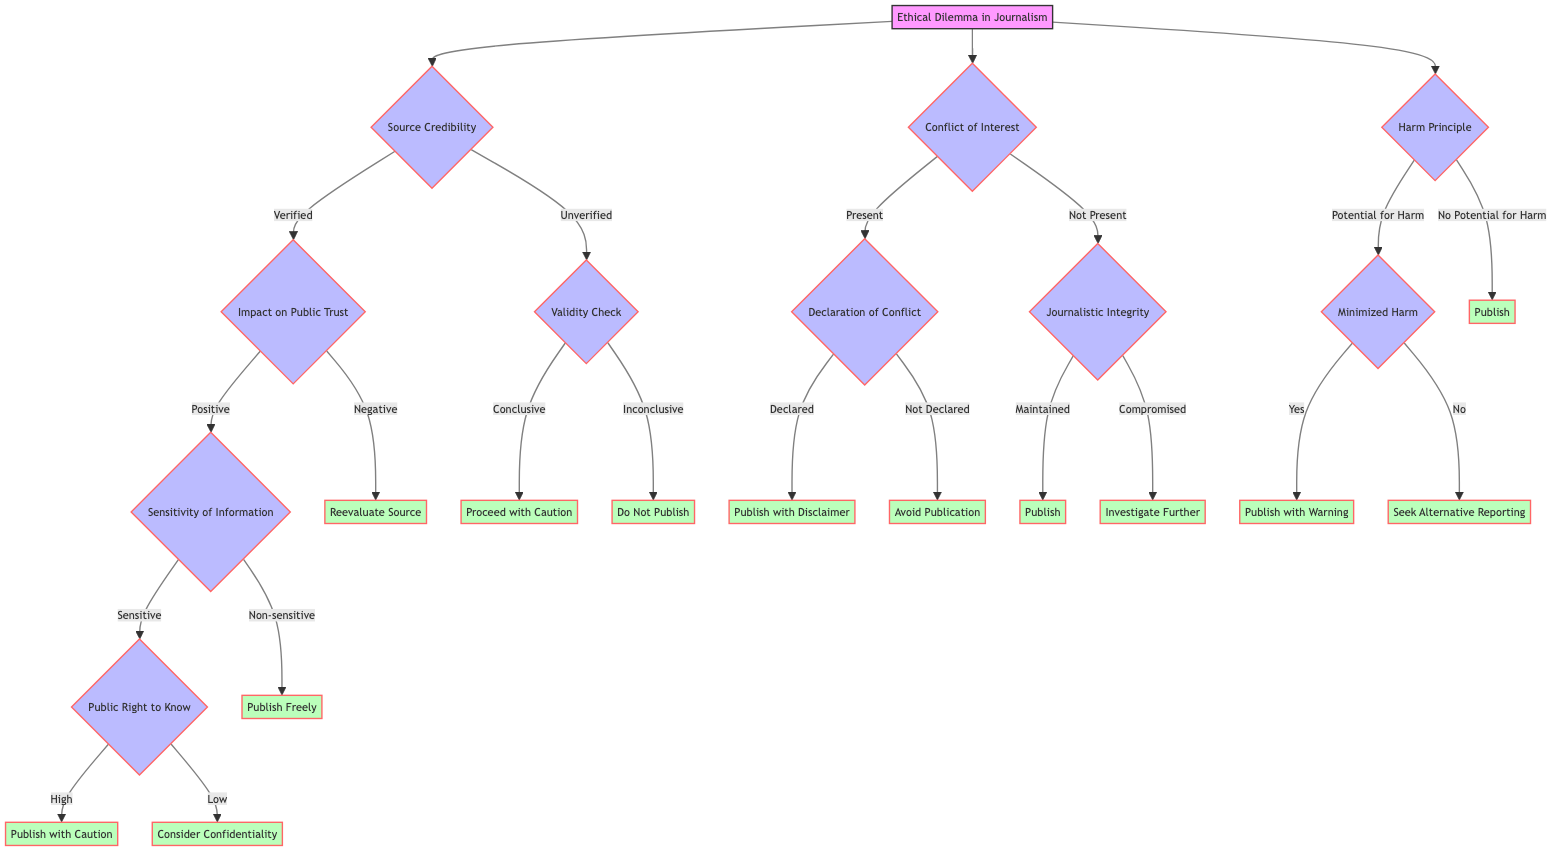What is the root node of the diagram? The root node represents the main decision point in the diagram, which is labeled as "Ethical Dilemma in Journalism."
Answer: Ethical Dilemma in Journalism How many main decision points are there in the diagram? The diagram has three main decision points branching out from the root: Source Credibility, Conflict of Interest, and Harm Principle.
Answer: 3 What outcome is reached when the source is verified and has a negative impact on public trust? Following the path, if the source is verified and has a negative impact, the outcome indicated is to "Reevaluate Source."
Answer: Reevaluate Source What happens if there is a potential for harm, but harm is minimized? If there is potential for harm but it is minimized, the next decision point asks whether to publish with a warning, which leads to the outcome "Publish with Warning."
Answer: Publish with Warning If there is a conflict of interest present but not declared, what should be done? In this case, the outcome is to "Avoid Publication" if the conflict of interest is not declared.
Answer: Avoid Publication What is the next decision point after identifying a verified source with a positive impact? After identifying a verified source with a positive impact, the next decision point is "Sensitivity of Information."
Answer: Sensitivity of Information What outcome directly follows the option "Maintained" under "Journalistic Integrity"? If journalistic integrity is maintained, the outcome specified is to "Publish."
Answer: Publish What is the outcome if the source is unverified and the evidence is inconclusive? If the source is unverified and evidence is inconclusive, the outcome is "Do Not Publish."
Answer: Do Not Publish If there is non-sensitive information after verifying the source, what is the outcome? In this situation, the outcome is simply "Publish Freely."
Answer: Publish Freely 